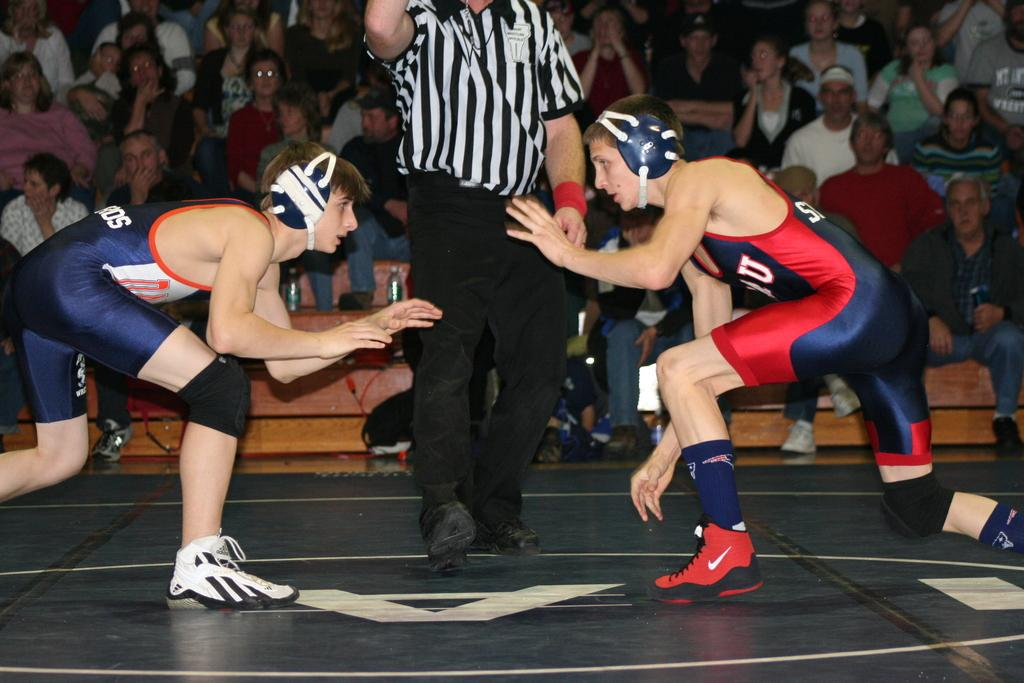<image>
Present a compact description of the photo's key features. Two men about to wrestle, one has a U on their outfit. 